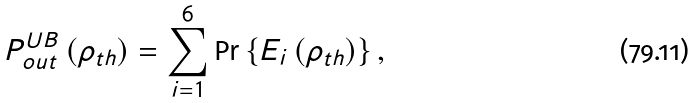<formula> <loc_0><loc_0><loc_500><loc_500>P _ { o u t } ^ { U B } \left ( \rho _ { t h } \right ) = \sum _ { i = 1 } ^ { 6 } \Pr \left \{ E _ { i } \left ( \rho _ { t h } \right ) \right \} ,</formula> 